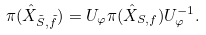Convert formula to latex. <formula><loc_0><loc_0><loc_500><loc_500>\pi ( \hat { X } _ { \tilde { S } , \tilde { f } } ) = U _ { \varphi } \pi ( \hat { X } _ { S , f } ) U ^ { - 1 } _ { \varphi } .</formula> 